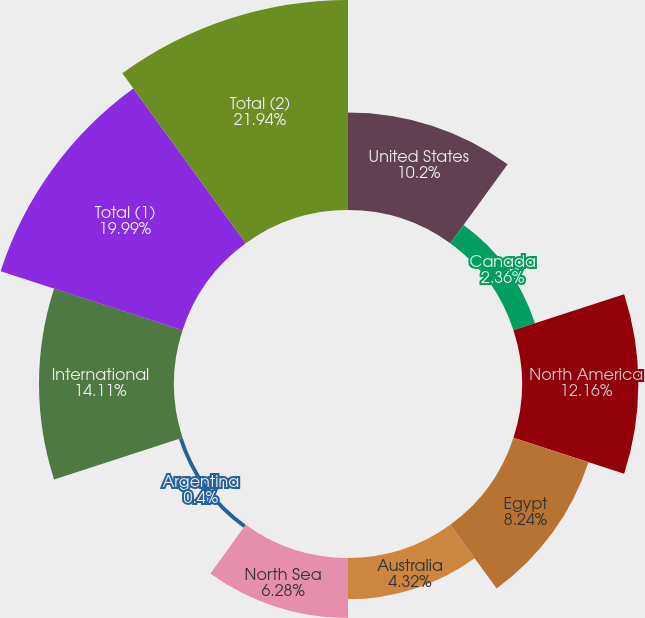Convert chart to OTSL. <chart><loc_0><loc_0><loc_500><loc_500><pie_chart><fcel>United States<fcel>Canada<fcel>North America<fcel>Egypt<fcel>Australia<fcel>North Sea<fcel>Argentina<fcel>International<fcel>Total (1)<fcel>Total (2)<nl><fcel>10.2%<fcel>2.36%<fcel>12.16%<fcel>8.24%<fcel>4.32%<fcel>6.28%<fcel>0.4%<fcel>14.11%<fcel>19.99%<fcel>21.95%<nl></chart> 